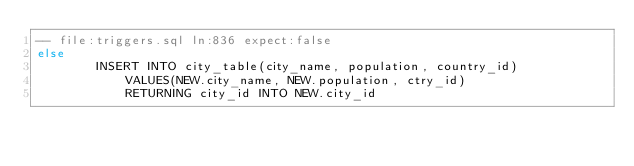Convert code to text. <code><loc_0><loc_0><loc_500><loc_500><_SQL_>-- file:triggers.sql ln:836 expect:false
else
        INSERT INTO city_table(city_name, population, country_id)
            VALUES(NEW.city_name, NEW.population, ctry_id)
            RETURNING city_id INTO NEW.city_id
</code> 